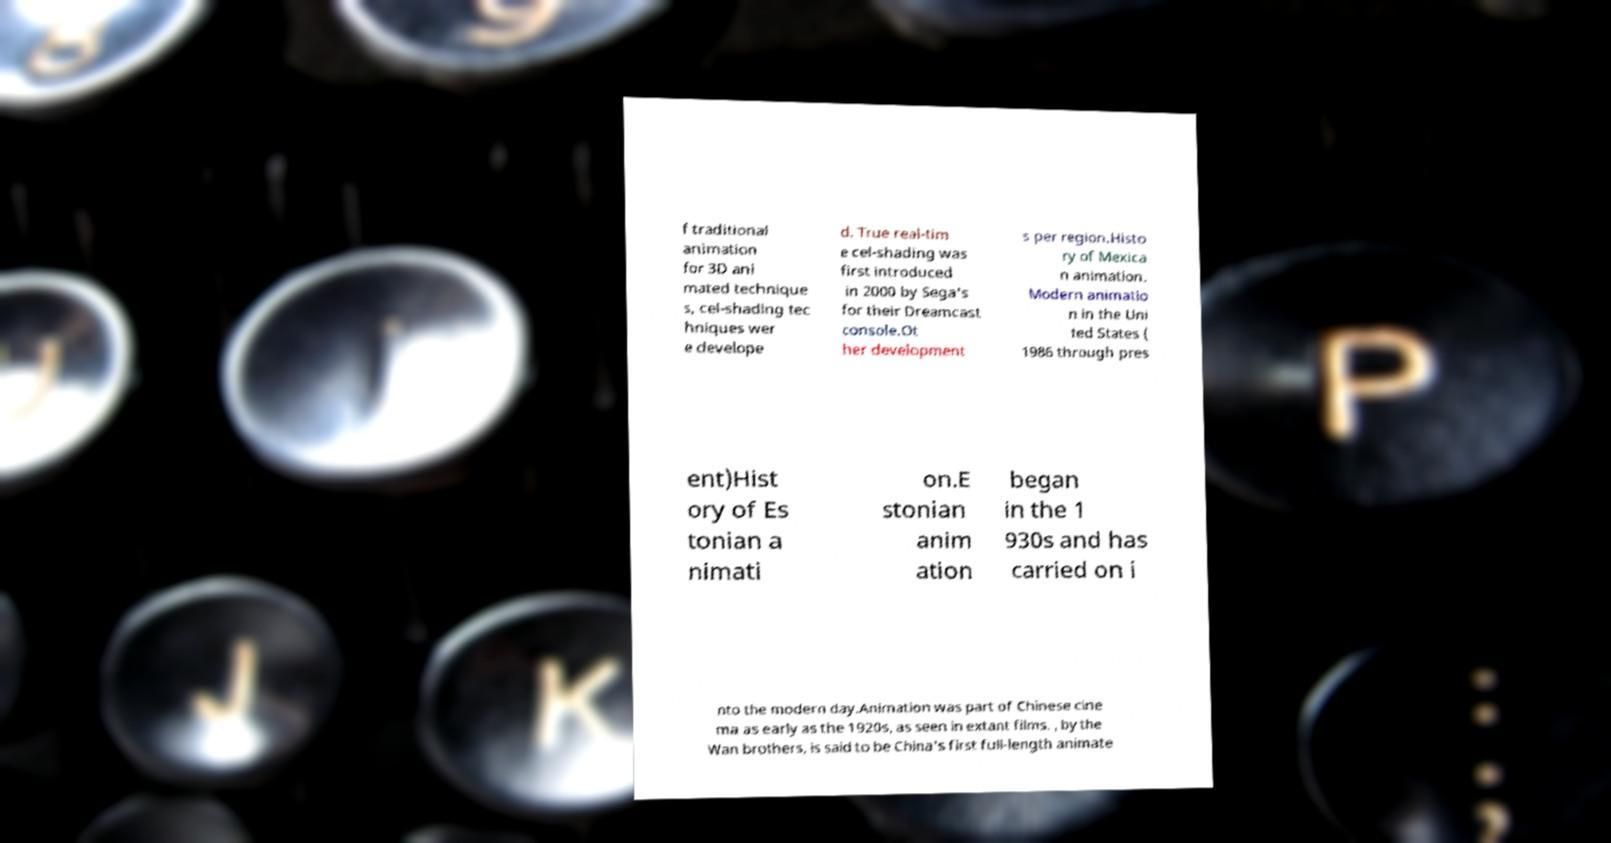Could you extract and type out the text from this image? f traditional animation for 3D ani mated technique s, cel-shading tec hniques wer e develope d. True real-tim e cel-shading was first introduced in 2000 by Sega's for their Dreamcast console.Ot her development s per region.Histo ry of Mexica n animation. Modern animatio n in the Uni ted States ( 1986 through pres ent)Hist ory of Es tonian a nimati on.E stonian anim ation began in the 1 930s and has carried on i nto the modern day.Animation was part of Chinese cine ma as early as the 1920s, as seen in extant films. , by the Wan brothers, is said to be China's first full-length animate 